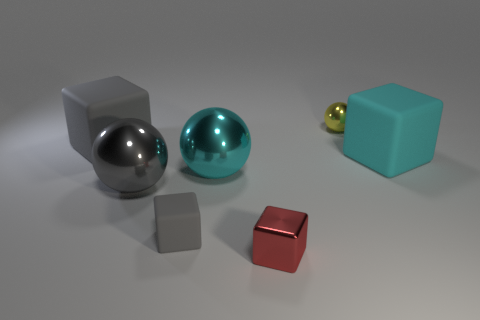What can you deduce about the scene's setting from the arrangement of the objects? Based on the arrangement of the objects, it seems to be a staged setting, likely for the purpose of a visual demonstration or exercise. The objects are intentionally placed with some space between them, on a neutral background that doesn't distract from their forms and colors. 